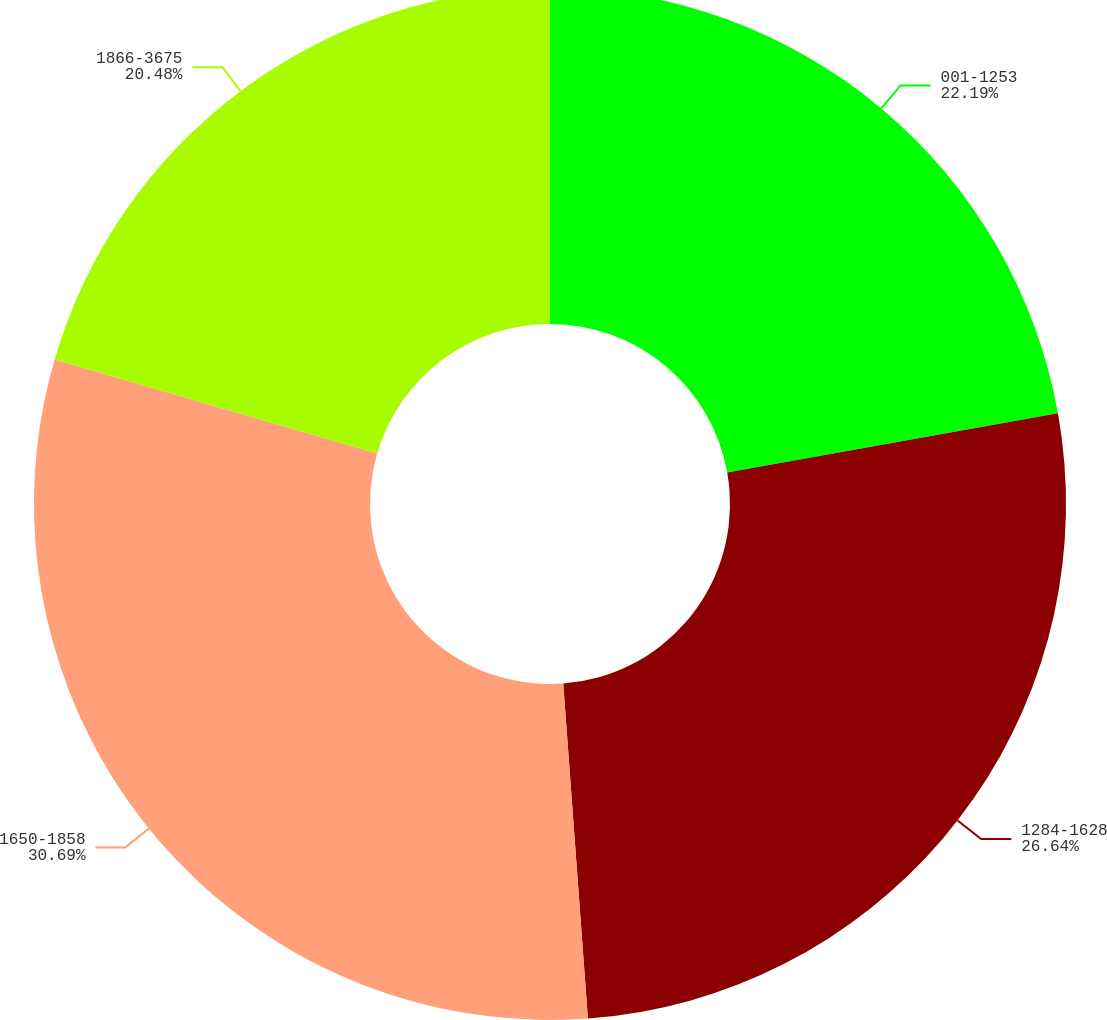Convert chart. <chart><loc_0><loc_0><loc_500><loc_500><pie_chart><fcel>001-1253<fcel>1284-1628<fcel>1650-1858<fcel>1866-3675<nl><fcel>22.19%<fcel>26.64%<fcel>30.69%<fcel>20.48%<nl></chart> 